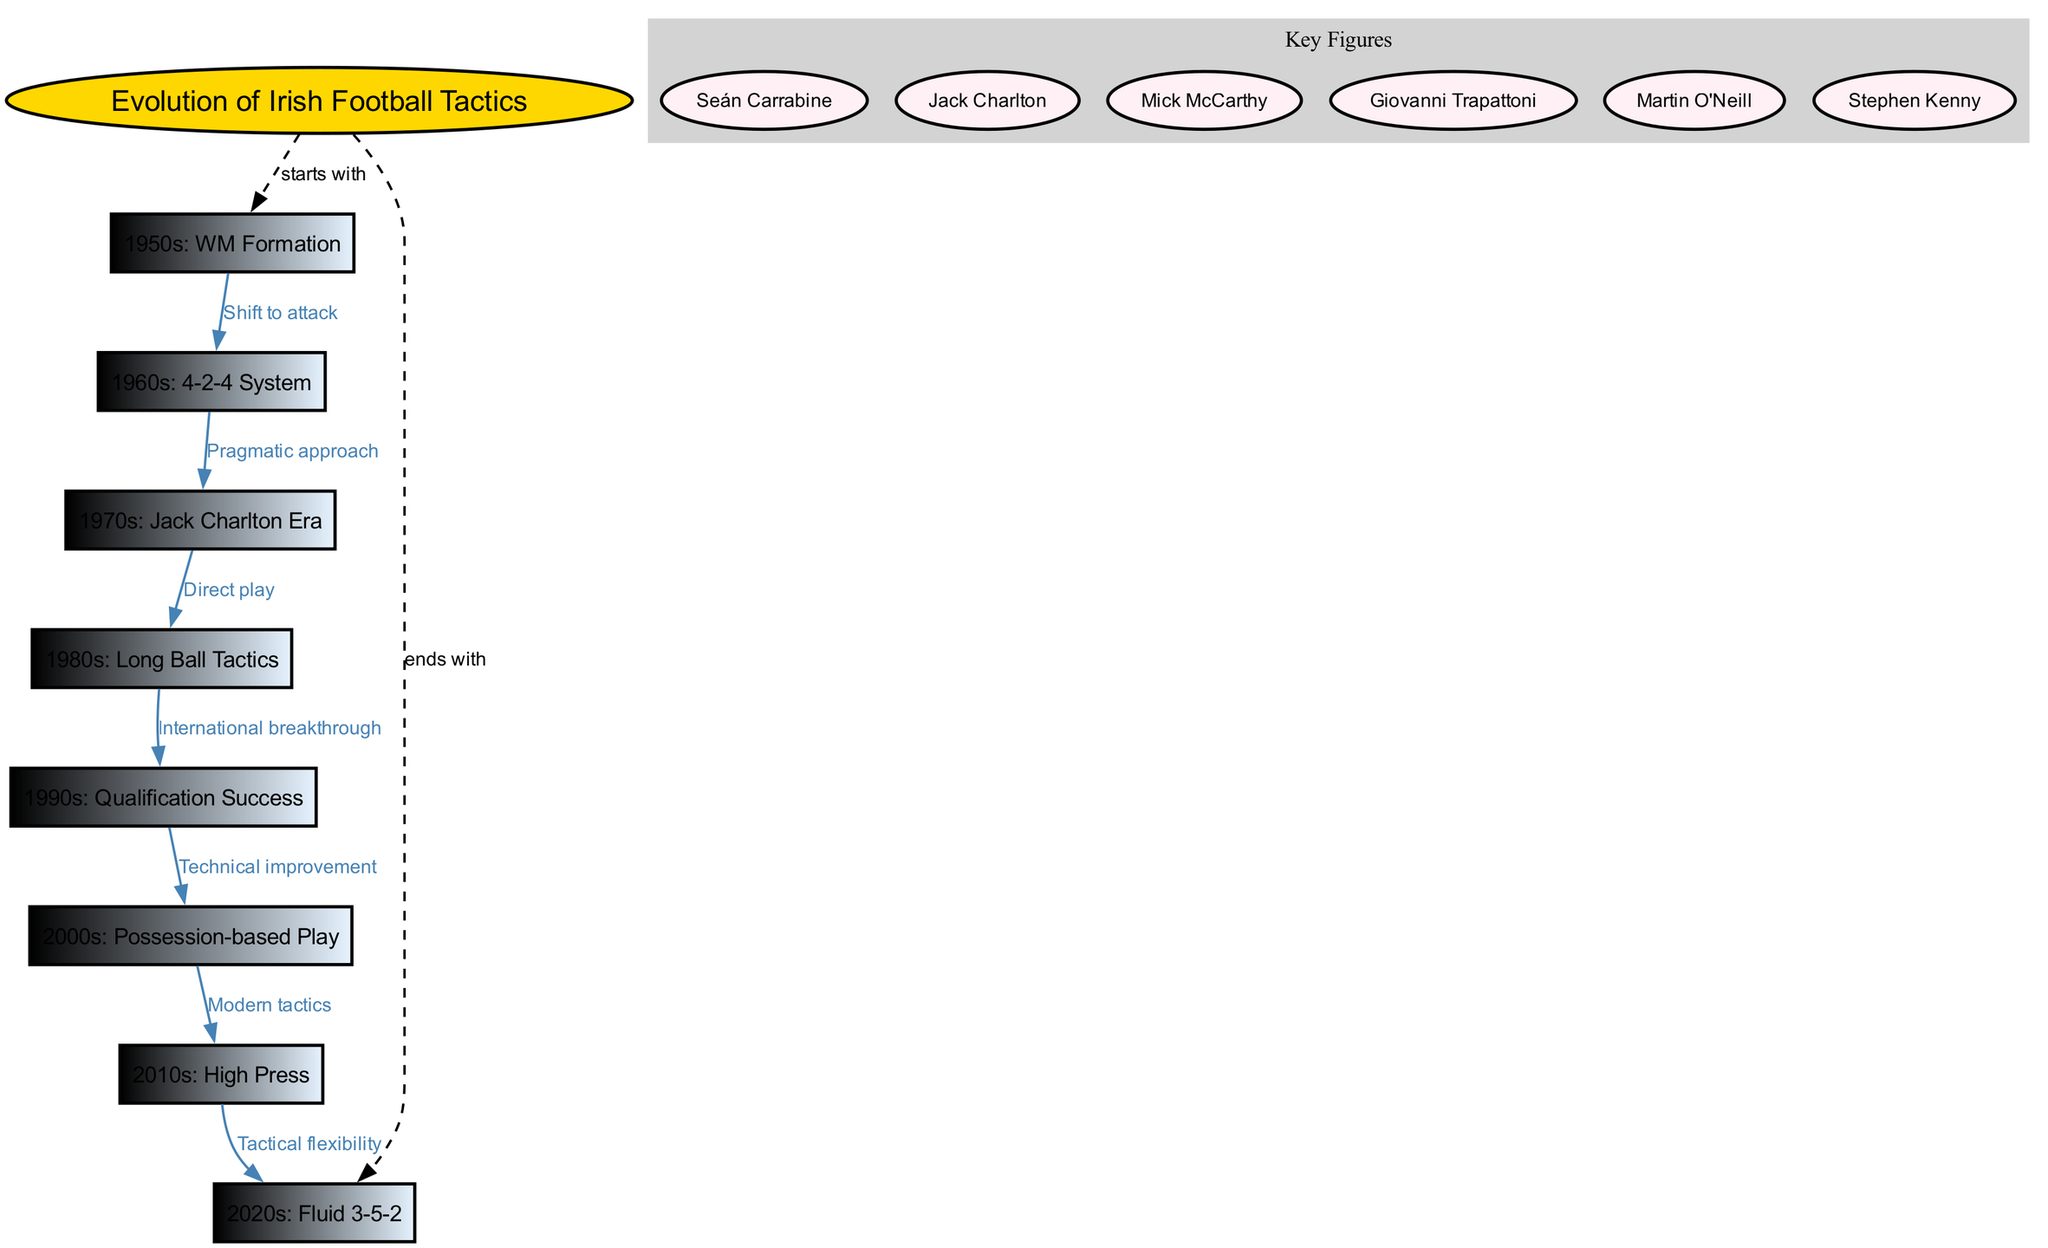What was the formation used in the 1950s? The diagram lists "1950s: WM Formation" as the node representing that era. It specifically names the formation used in that timeframe.
Answer: WM Formation How many key figures are mentioned in the diagram? By looking at the "Key Figures" section in the diagram, it lists six notable figures associated with the evolution of tactics. Thus, the total count is determined to be six.
Answer: 6 What tactic characterized the 1980s in Irish football? The diagram clearly identifies "1980s: Long Ball Tactics" as a significant tactic during that decade, pointing out its importance within the evolution flow.
Answer: Long Ball Tactics What connects the 1960s and 1970s nodes? The connection from "1960s: 4-2-4 System" to "1970s: Jack Charlton Era" is marked as a "Pragmatic approach", indicating the reasoning behind the transition between these styles of play.
Answer: Pragmatic approach Which era followed the tactical flexibility of the 2010s? The diagram shows that after "2010s: High Press", the next evolution of tactics was "2020s: Fluid 3-5-2", indicating an immediate progression in tactical styles.
Answer: 2020s: Fluid 3-5-2 What was the main feature of the transition from the 1990s to the 2000s? The relation from "1990s: Qualification Success" to "2000s: Possession-based Play" is characterized by "Technical improvement", linking the two nodes and showing the reason for this tactical evolution.
Answer: Technical improvement From which era did direct play arise as a tactic? The connection labeled as "Direct play" links "1970s: Jack Charlton Era" to "1980s: Long Ball Tactics", indicating that the tactical feature arose specifically during that timeframe.
Answer: 1970s: Jack Charlton Era Which formation is associated with the modern tactics of the 2000s? The diagram shows that "2000s: Possession-based Play" is connected in a logical flow leading towards "2010s: High Press", suggesting that this was the modern evolution of tactics during those years.
Answer: Possession-based Play How did the style of play evolve from the 2010s to the 2020s? The transition from "2010s: High Press" to "2020s: Fluid 3-5-2" is described as "Tactical flexibility", implying a shift towards a more adaptable style of play in the following decade.
Answer: Tactical flexibility 